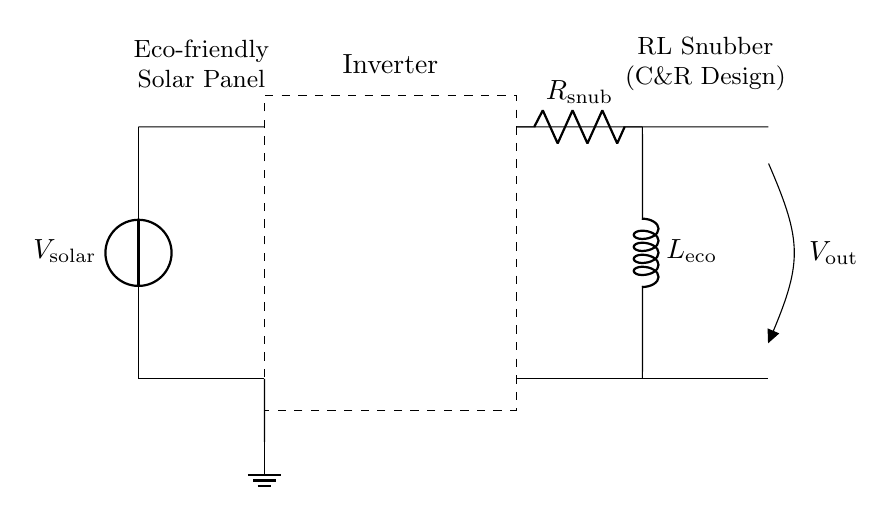What is the voltage source in this circuit? The voltage source, labeled as V solar, is located on the left side of the diagram and represents the solar panel voltage output.
Answer: V solar What component is used to limit the rate of current change? The inductor, labeled as L eco, is responsible for limiting the rate of current change in the RL snubber circuit, allowing it to manage current fluctuations effectively.
Answer: L eco What is the purpose of the resistor in this circuit? The resistor, labeled as R snub, serves to dissipate energy and reduce voltage spikes caused by rapid changes in current, helping protect the inverter.
Answer: R snub How many components are there in the RL snubber section? There are two components in the RL snubber section, comprising one resistor and one inductor, connected in series.
Answer: Two What connects the inverter to the RL snubber? A short connection from the inverter outputs connects directly to the RL snubber circuit, indicating that the inverter's output feeds into the RL snubber for additional protection.
Answer: Short connection What is the function of the dashed rectangle in the diagram? The dashed rectangle represents the inverter, indicating where the conversion from direct current (DC) from the solar panel to alternating current (AC) occurs.
Answer: Inverter Where does the energy from the solar panel output go? The energy from the solar panel output, represented by the voltage source, flows through the inverter and then through the RL snubber before reaching the output.
Answer: To the output 